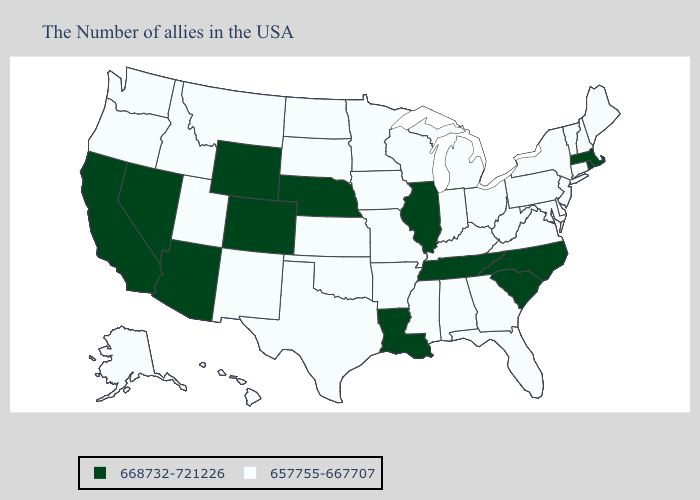Which states have the lowest value in the USA?
Quick response, please. Maine, New Hampshire, Vermont, Connecticut, New York, New Jersey, Delaware, Maryland, Pennsylvania, Virginia, West Virginia, Ohio, Florida, Georgia, Michigan, Kentucky, Indiana, Alabama, Wisconsin, Mississippi, Missouri, Arkansas, Minnesota, Iowa, Kansas, Oklahoma, Texas, South Dakota, North Dakota, New Mexico, Utah, Montana, Idaho, Washington, Oregon, Alaska, Hawaii. Name the states that have a value in the range 668732-721226?
Be succinct. Massachusetts, Rhode Island, North Carolina, South Carolina, Tennessee, Illinois, Louisiana, Nebraska, Wyoming, Colorado, Arizona, Nevada, California. Name the states that have a value in the range 668732-721226?
Keep it brief. Massachusetts, Rhode Island, North Carolina, South Carolina, Tennessee, Illinois, Louisiana, Nebraska, Wyoming, Colorado, Arizona, Nevada, California. Among the states that border Idaho , does Washington have the lowest value?
Keep it brief. Yes. Does North Carolina have the highest value in the USA?
Be succinct. Yes. Among the states that border Maine , which have the lowest value?
Give a very brief answer. New Hampshire. Name the states that have a value in the range 657755-667707?
Concise answer only. Maine, New Hampshire, Vermont, Connecticut, New York, New Jersey, Delaware, Maryland, Pennsylvania, Virginia, West Virginia, Ohio, Florida, Georgia, Michigan, Kentucky, Indiana, Alabama, Wisconsin, Mississippi, Missouri, Arkansas, Minnesota, Iowa, Kansas, Oklahoma, Texas, South Dakota, North Dakota, New Mexico, Utah, Montana, Idaho, Washington, Oregon, Alaska, Hawaii. Among the states that border Arkansas , which have the highest value?
Give a very brief answer. Tennessee, Louisiana. What is the lowest value in states that border Washington?
Concise answer only. 657755-667707. Which states have the lowest value in the West?
Concise answer only. New Mexico, Utah, Montana, Idaho, Washington, Oregon, Alaska, Hawaii. Does Wisconsin have a higher value than Virginia?
Write a very short answer. No. What is the highest value in the Northeast ?
Give a very brief answer. 668732-721226. Name the states that have a value in the range 668732-721226?
Be succinct. Massachusetts, Rhode Island, North Carolina, South Carolina, Tennessee, Illinois, Louisiana, Nebraska, Wyoming, Colorado, Arizona, Nevada, California. Does Connecticut have a lower value than Washington?
Keep it brief. No. Among the states that border Colorado , which have the highest value?
Short answer required. Nebraska, Wyoming, Arizona. 